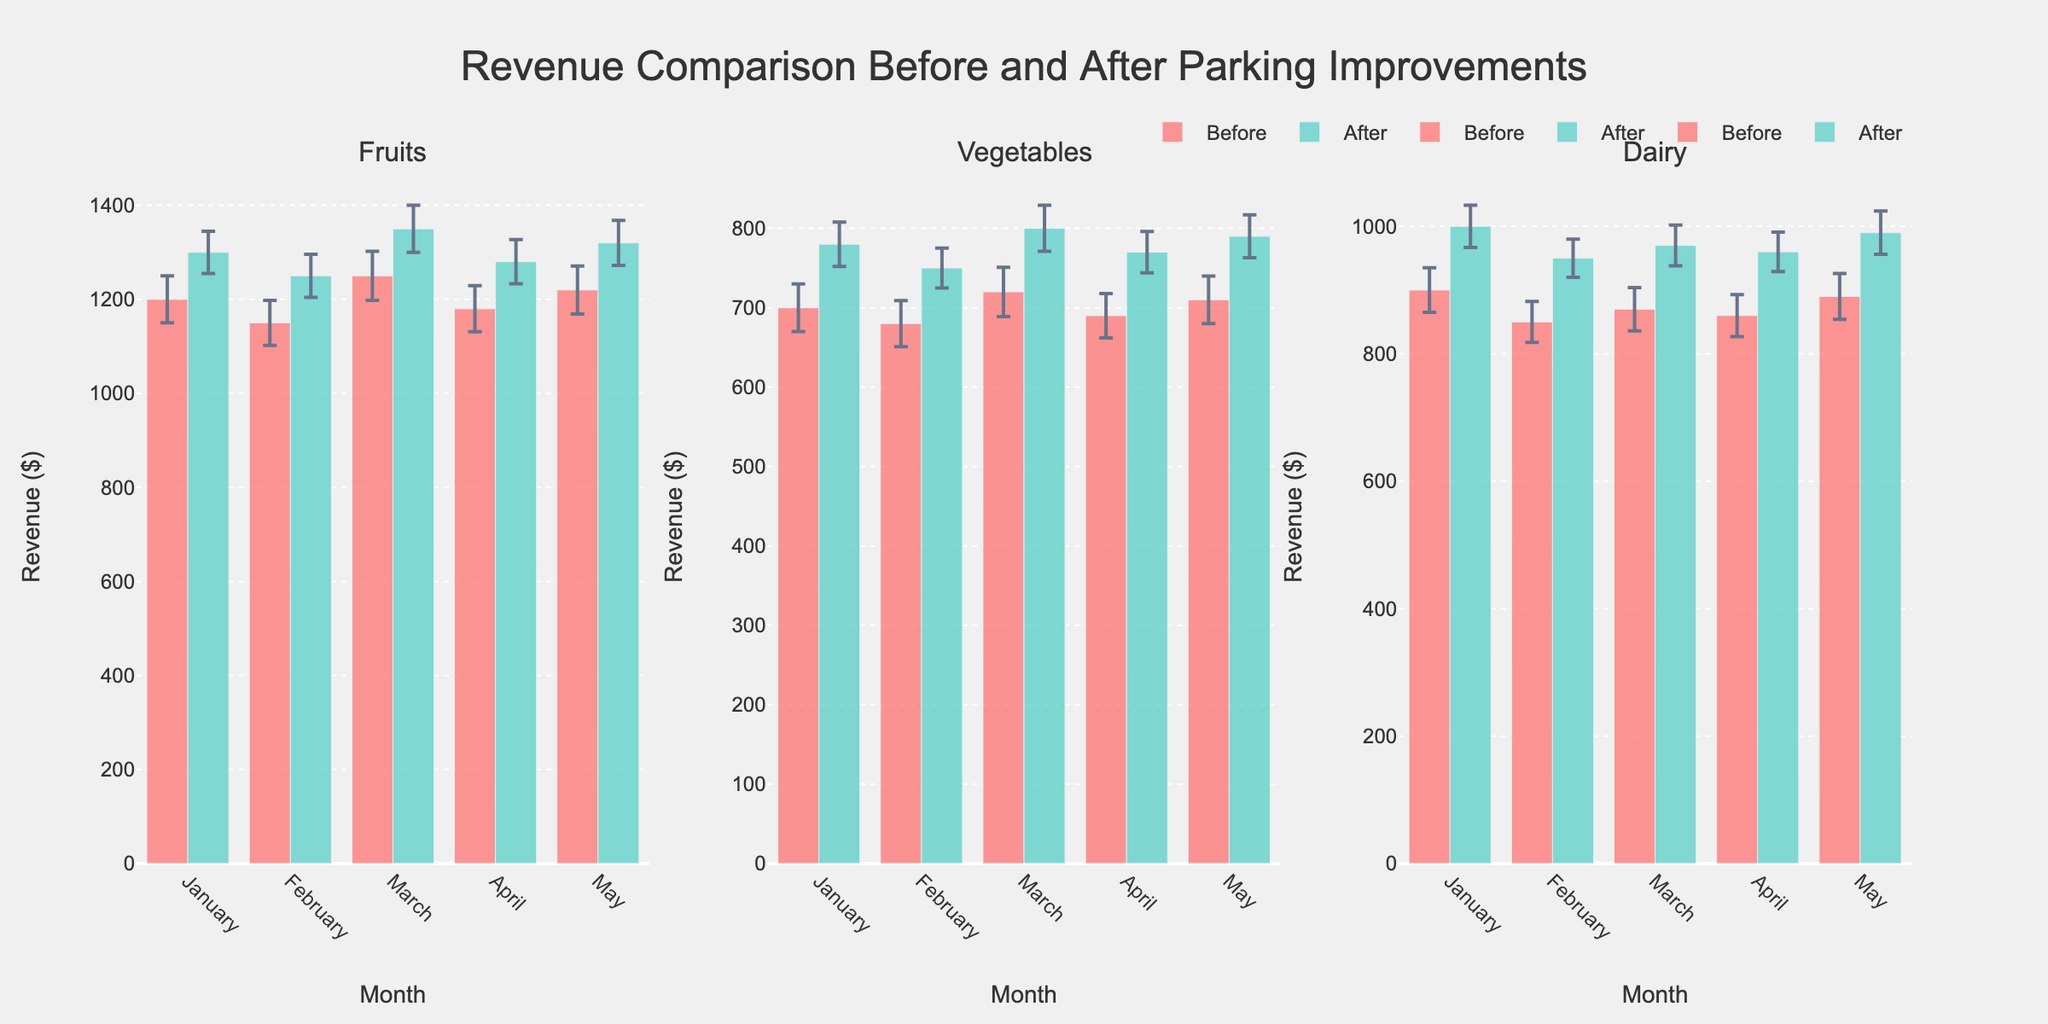What's the title of the figure? The title is usually located at the top of the figure. In this figure, the title is "Revenue Comparison Before and After Parking Improvements".
Answer: Revenue Comparison Before and After Parking Improvements Which color represents revenue before the parking improvements? The color legend for before and after the improvements is provided. The color representing revenue before is the first color listed, which is '#FF6B6B'. In natural language, it is a shade of red.
Answer: Red In which month and category was the highest revenue recorded after the parking improvements? To find this, we look at the highest bar in the "After" category across all subplots. This occurs in the "Fruits" category in March, where the revenue is 1350.
Answer: March, Fruits What is the average revenue from dairy products after parking improvements? To calculate the average revenue, sum the revenue for dairy products after improvements and divide by the number of months: (1000 + 950 + 970 + 960 + 990) / 5 = 4870 / 5 = 974.
Answer: 974 How does the revenue from vegetables in January before improvements compare to that after improvements? Compare the revenue of vegetables in January before (700) and after (780) improvements: 780 is higher than 700.
Answer: After improvements revenue is higher Which category saw the most significant increase in revenue from February to March after parking improvements? Calculate the difference for each category from February to March after improvements: Fruits (1350-1250=100), Vegetables (800-750=50), Dairy (970-950=20). The largest increase is in Fruits.
Answer: Fruits By how much did the revenue for dairy products increase from January to February after parking improvements? Subtract the January revenue for dairy products after improvements (1000) from February revenue (950): 1000 - 950 = 50.
Answer: 50 Which category had the least fluctuation in revenue after improvements across the months, and how does it compare to its fluctuation before improvements? To determine this, we compare the error bars (indicating fluctuation) for each category after improvements. Vegetables have the smallest: 28, 25, 29, 26, 27. Compare with before: 30, 29, 31, 28, 30. Vegetables also have the least fluctuation before.
Answer: Vegetables had the least fluctuation before and after How much was the total revenue for fruits in April before and after the parking improvements? Sum up the before and after revenues for fruits in April: 1180 (before) + 1280 (after) = 2460.
Answer: 2460 